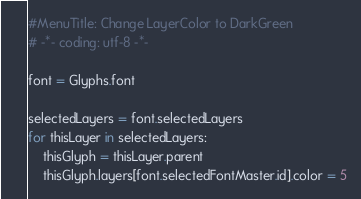Convert code to text. <code><loc_0><loc_0><loc_500><loc_500><_Python_>#MenuTitle: Change LayerColor to DarkGreen
# -*- coding: utf-8 -*-

font = Glyphs.font

selectedLayers = font.selectedLayers
for thisLayer in selectedLayers:
	thisGlyph = thisLayer.parent
	thisGlyph.layers[font.selectedFontMaster.id].color = 5
</code> 